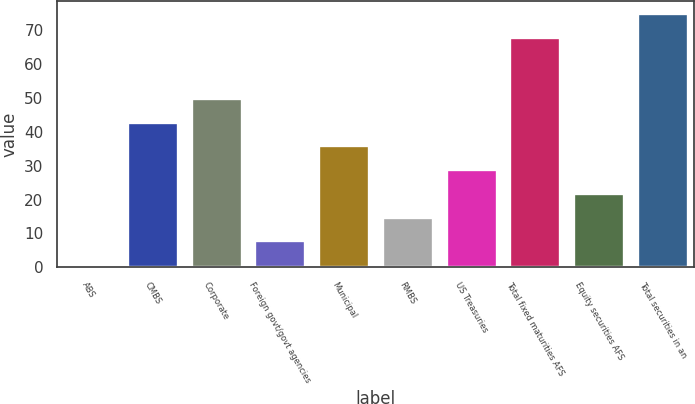<chart> <loc_0><loc_0><loc_500><loc_500><bar_chart><fcel>ABS<fcel>CMBS<fcel>Corporate<fcel>Foreign govt/govt agencies<fcel>Municipal<fcel>RMBS<fcel>US Treasuries<fcel>Total fixed maturities AFS<fcel>Equity securities AFS<fcel>Total securities in an<nl><fcel>1<fcel>43<fcel>50<fcel>8<fcel>36<fcel>15<fcel>29<fcel>68<fcel>22<fcel>75<nl></chart> 